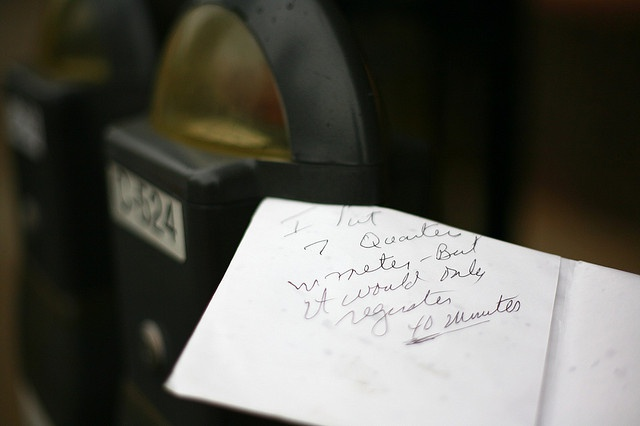Describe the objects in this image and their specific colors. I can see parking meter in black, darkgreen, and gray tones and parking meter in black and gray tones in this image. 